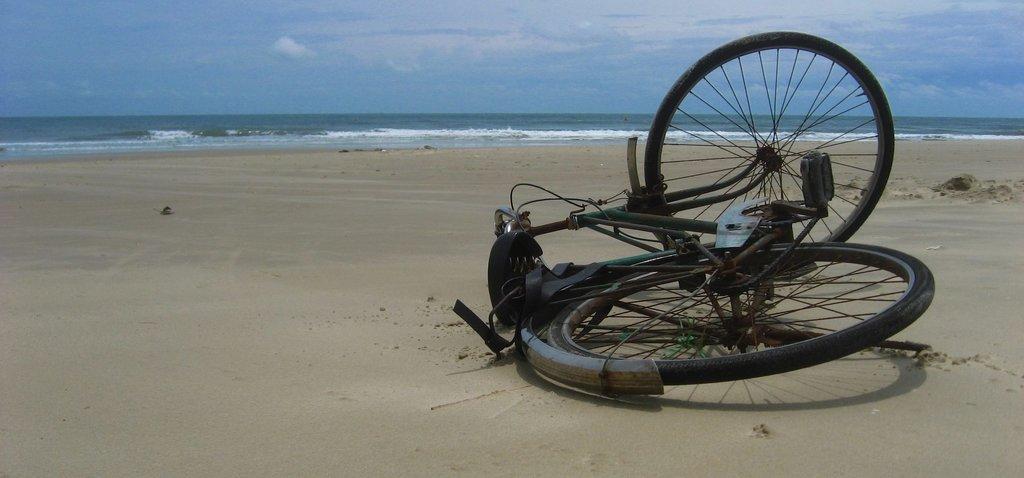In one or two sentences, can you explain what this image depicts? In this picture we can see a bicycle on the ground and in the background we can see water, sky with clouds. 